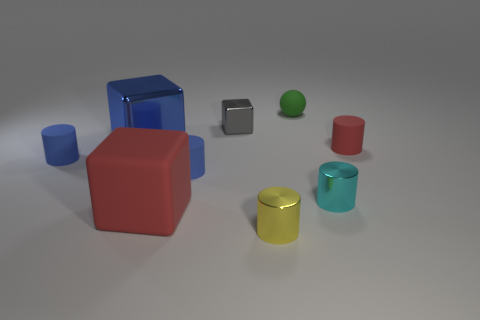What size is the red rubber cylinder that is behind the tiny metal cylinder to the right of the yellow shiny cylinder?
Offer a very short reply. Small. Do the tiny cylinder that is on the left side of the matte cube and the red object behind the cyan metal thing have the same material?
Give a very brief answer. Yes. Do the matte cylinder that is on the right side of the small yellow thing and the big matte block have the same color?
Provide a succinct answer. Yes. How many large blue metal cubes are on the left side of the small green matte sphere?
Make the answer very short. 1. Do the tiny gray object and the tiny cylinder in front of the matte block have the same material?
Provide a short and direct response. Yes. What size is the yellow object that is the same material as the small cube?
Offer a terse response. Small. Is the number of tiny metal objects behind the tiny cyan shiny thing greater than the number of things in front of the yellow metal cylinder?
Ensure brevity in your answer.  Yes. Are there any tiny red matte things of the same shape as the yellow shiny thing?
Keep it short and to the point. Yes. There is a rubber cylinder that is to the left of the red cube; does it have the same size as the red rubber cube?
Keep it short and to the point. No. Is there a large purple shiny cube?
Provide a short and direct response. No. 